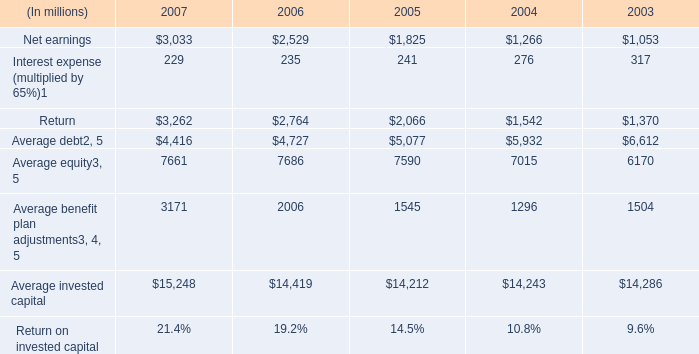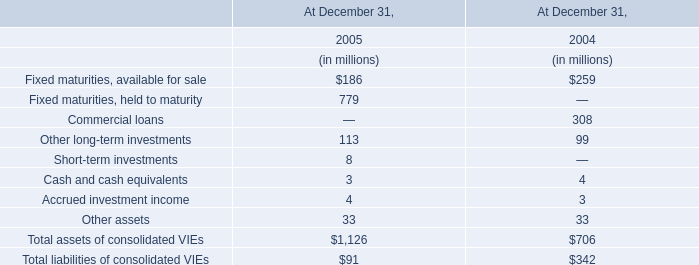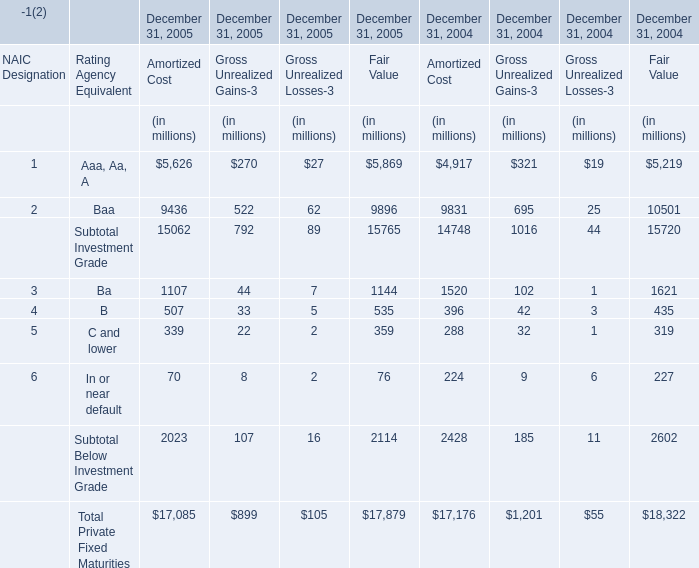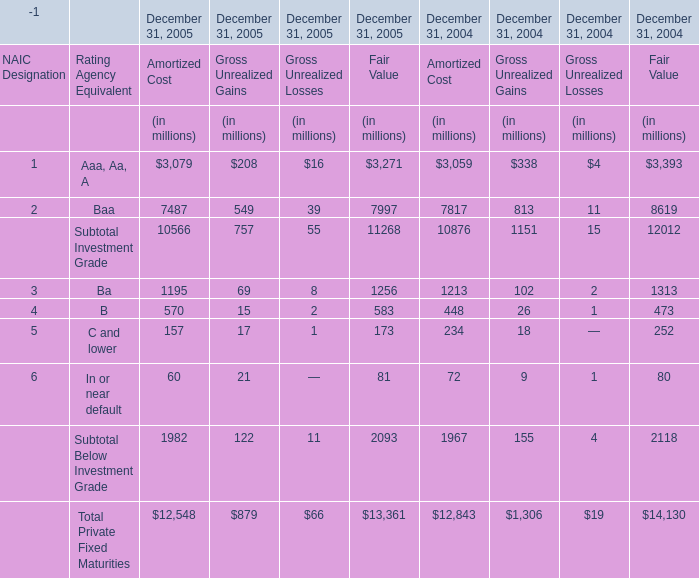What was the sum of amortized cost without those private fixed maturities smaller than 5000，in 2005? (in million) 
Computations: (((1107 + 507) + 339) + 70)
Answer: 2023.0. 